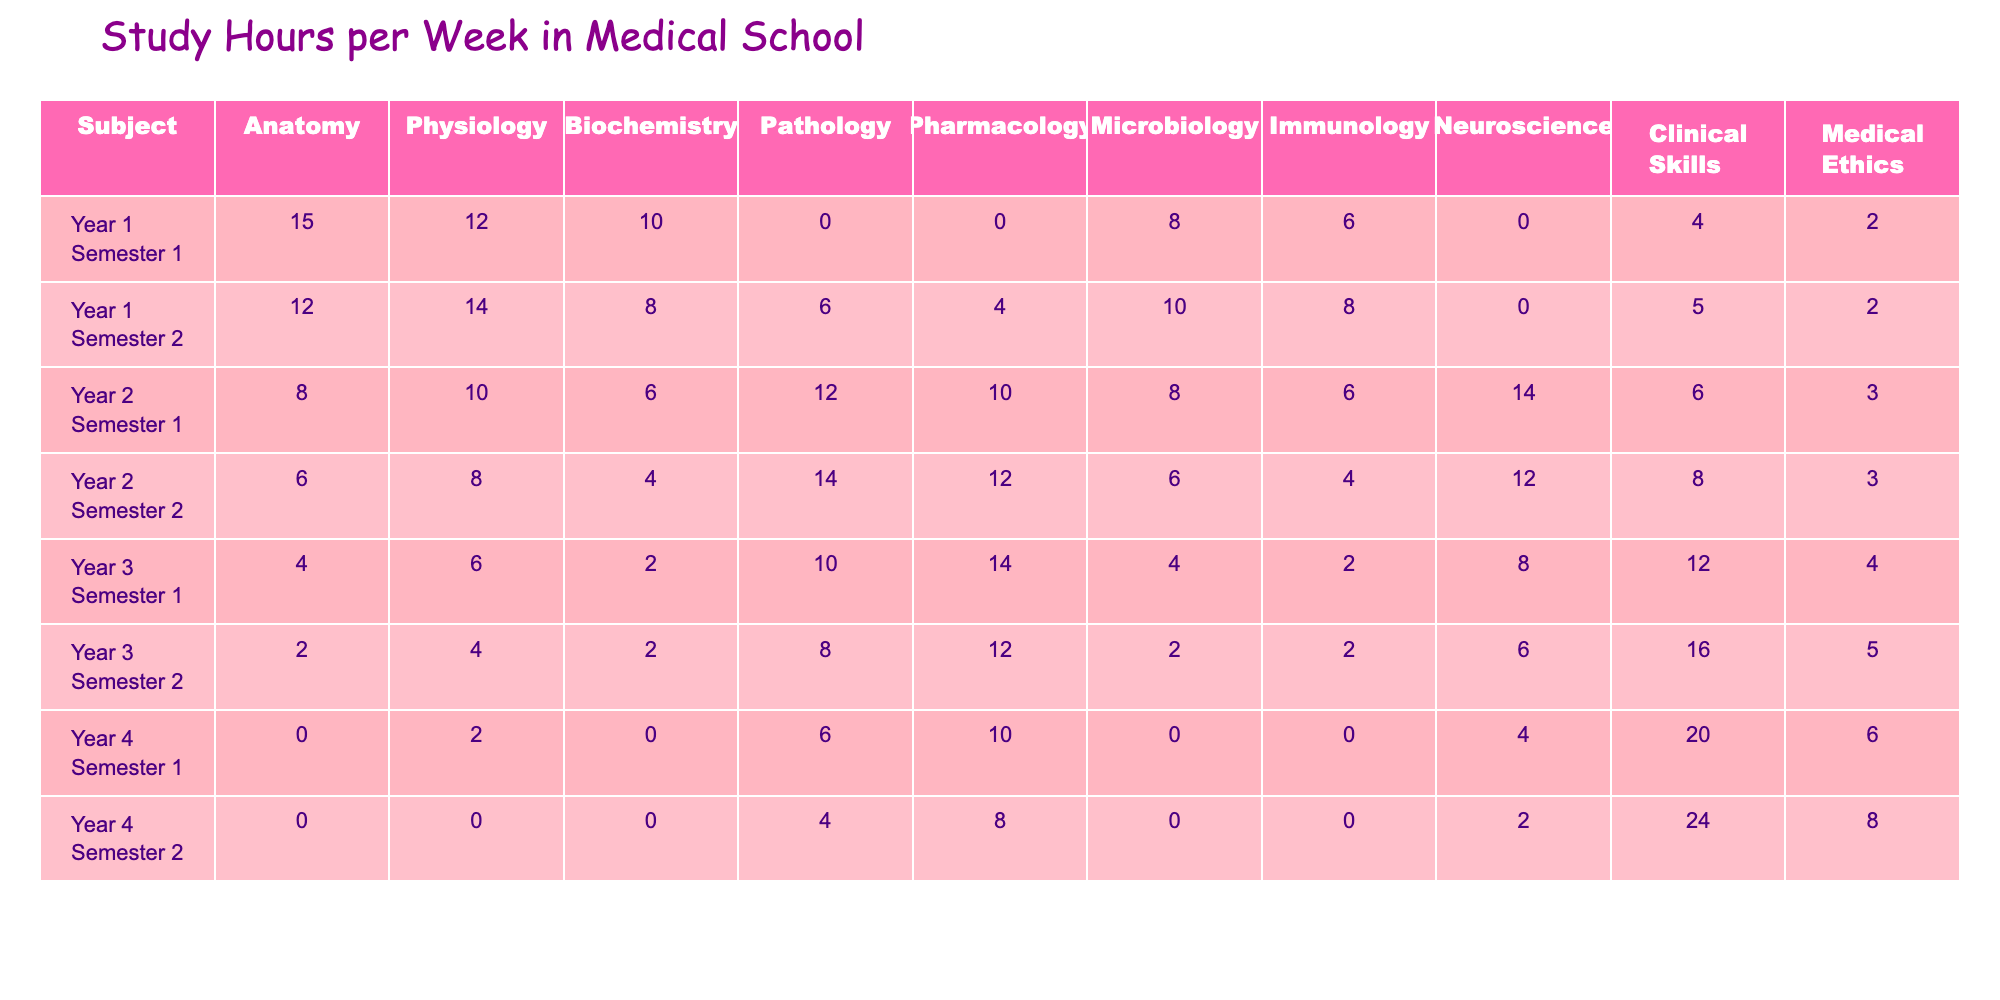What is the subject with the highest study hours in Year 1 Semester 1? In Year 1 Semester 1, looking at the hours, Anatomy has 15 hours, which is the highest compared to other subjects.
Answer: Anatomy What are the total study hours for Physiology across all semesters? Adding the study hours for Physiology from each semester: 12 + 14 + 10 + 8 + 6 + 4 + 2 + 0 = 56.
Answer: 56 Was there ever a semester where Clinical Skills had 0 study hours? Yes, Clinical Skills had 0 study hours in Year 4 Semester 1 and Year 4 Semester 2.
Answer: Yes Which subject saw the biggest increase in study hours from Year 2 Semester 1 to Year 2 Semester 2? Comparing the two semesters for each subject, Pathology increased from 12 to 14 hours, which is a 2-hour increase, more than any other subject.
Answer: Pathology What is the average number of study hours for Biochemistry in Year 3? For Year 3, Biochemistry study hours are 2 hours in Semester 1 and 2 hours in Semester 2. The total is 2 + 2 = 4 hours, and dividing by 2 gives an average of 2 hours.
Answer: 2 Which subject had the highest overall study hours across all semesters? We need to sum the hours for each subject across all semesters. The totals show that Anatomy has the highest total with 15+12+8+6+4+2 = 47.
Answer: Anatomy In which semester was there the least amount of study hours for Immunology? Checking all semesters for Immunology, Year 4 Semester 1 and Year 4 Semester 2 both have 0 study hours, which is the least.
Answer: Year 4 Semester 1 and Year 4 Semester 2 What is the difference in study hours for Pathology between Year 1 Semester 2 and Year 3 Semester 1? Pathology had 6 hours in Year 1 Semester 2 and 10 hours in Year 3 Semester 1. The difference is 10 - 6 = 4 hours.
Answer: 4 Which semester had the highest total study hours across all subjects? Calculating the total study hours for each semester shows Year 4 Semester 2 has the highest total with 0+0+0+4+8+0+0+2+24+8 = 46 hours.
Answer: Year 4 Semester 2 